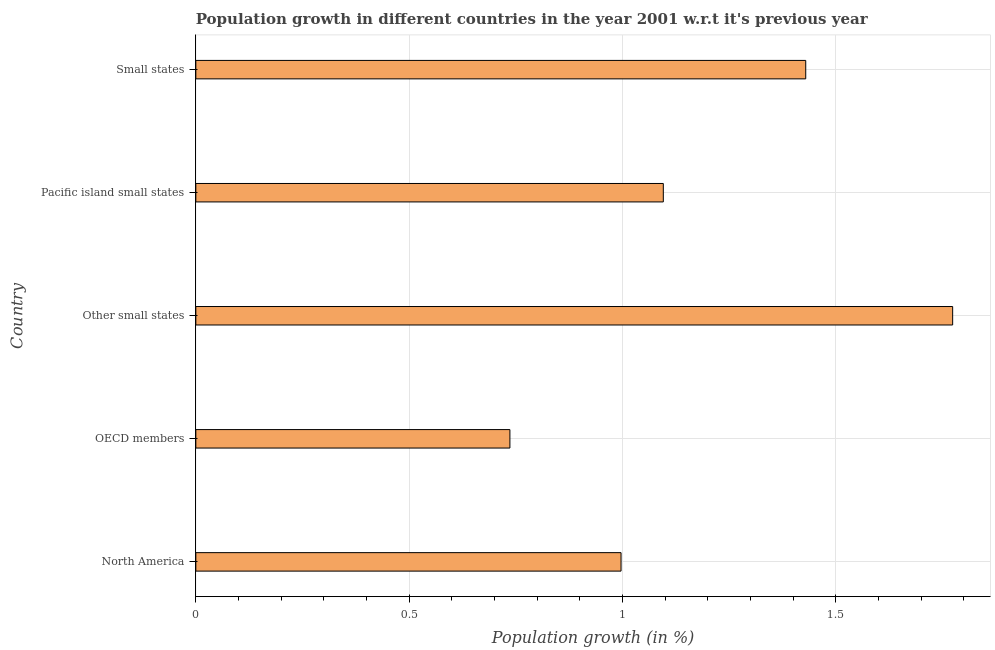Does the graph contain any zero values?
Your answer should be compact. No. Does the graph contain grids?
Ensure brevity in your answer.  Yes. What is the title of the graph?
Keep it short and to the point. Population growth in different countries in the year 2001 w.r.t it's previous year. What is the label or title of the X-axis?
Your answer should be compact. Population growth (in %). What is the population growth in OECD members?
Keep it short and to the point. 0.74. Across all countries, what is the maximum population growth?
Your answer should be compact. 1.77. Across all countries, what is the minimum population growth?
Offer a very short reply. 0.74. In which country was the population growth maximum?
Provide a short and direct response. Other small states. What is the sum of the population growth?
Make the answer very short. 6.03. What is the difference between the population growth in North America and Small states?
Your response must be concise. -0.43. What is the average population growth per country?
Offer a terse response. 1.21. What is the median population growth?
Give a very brief answer. 1.1. In how many countries, is the population growth greater than 1.1 %?
Keep it short and to the point. 2. What is the ratio of the population growth in North America to that in Small states?
Give a very brief answer. 0.7. Is the difference between the population growth in OECD members and Small states greater than the difference between any two countries?
Make the answer very short. No. What is the difference between the highest and the second highest population growth?
Keep it short and to the point. 0.34. Is the sum of the population growth in Other small states and Small states greater than the maximum population growth across all countries?
Your answer should be compact. Yes. What is the difference between the highest and the lowest population growth?
Your answer should be compact. 1.04. How many bars are there?
Offer a very short reply. 5. Are all the bars in the graph horizontal?
Offer a terse response. Yes. What is the difference between two consecutive major ticks on the X-axis?
Give a very brief answer. 0.5. What is the Population growth (in %) of North America?
Make the answer very short. 1. What is the Population growth (in %) of OECD members?
Offer a very short reply. 0.74. What is the Population growth (in %) of Other small states?
Provide a short and direct response. 1.77. What is the Population growth (in %) of Pacific island small states?
Your answer should be very brief. 1.1. What is the Population growth (in %) in Small states?
Offer a terse response. 1.43. What is the difference between the Population growth (in %) in North America and OECD members?
Your answer should be compact. 0.26. What is the difference between the Population growth (in %) in North America and Other small states?
Give a very brief answer. -0.78. What is the difference between the Population growth (in %) in North America and Pacific island small states?
Offer a terse response. -0.1. What is the difference between the Population growth (in %) in North America and Small states?
Make the answer very short. -0.43. What is the difference between the Population growth (in %) in OECD members and Other small states?
Give a very brief answer. -1.04. What is the difference between the Population growth (in %) in OECD members and Pacific island small states?
Ensure brevity in your answer.  -0.36. What is the difference between the Population growth (in %) in OECD members and Small states?
Ensure brevity in your answer.  -0.69. What is the difference between the Population growth (in %) in Other small states and Pacific island small states?
Offer a terse response. 0.68. What is the difference between the Population growth (in %) in Other small states and Small states?
Offer a very short reply. 0.34. What is the difference between the Population growth (in %) in Pacific island small states and Small states?
Your answer should be very brief. -0.33. What is the ratio of the Population growth (in %) in North America to that in OECD members?
Your response must be concise. 1.35. What is the ratio of the Population growth (in %) in North America to that in Other small states?
Your response must be concise. 0.56. What is the ratio of the Population growth (in %) in North America to that in Pacific island small states?
Ensure brevity in your answer.  0.91. What is the ratio of the Population growth (in %) in North America to that in Small states?
Offer a very short reply. 0.7. What is the ratio of the Population growth (in %) in OECD members to that in Other small states?
Offer a terse response. 0.41. What is the ratio of the Population growth (in %) in OECD members to that in Pacific island small states?
Offer a terse response. 0.67. What is the ratio of the Population growth (in %) in OECD members to that in Small states?
Your response must be concise. 0.52. What is the ratio of the Population growth (in %) in Other small states to that in Pacific island small states?
Your answer should be compact. 1.62. What is the ratio of the Population growth (in %) in Other small states to that in Small states?
Provide a short and direct response. 1.24. What is the ratio of the Population growth (in %) in Pacific island small states to that in Small states?
Your answer should be very brief. 0.77. 